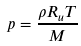Convert formula to latex. <formula><loc_0><loc_0><loc_500><loc_500>p = { \frac { \rho R _ { u } T } { M } }</formula> 